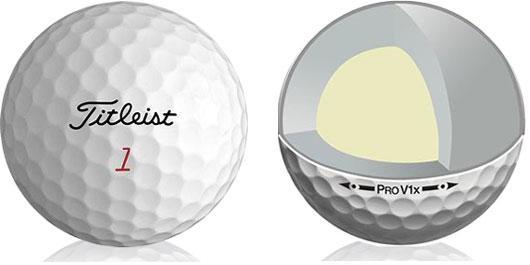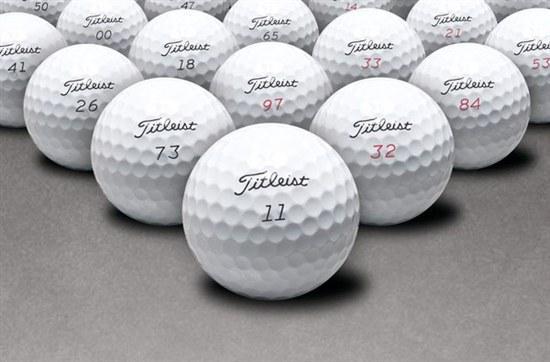The first image is the image on the left, the second image is the image on the right. Assess this claim about the two images: "There are exactly two golf balls". Correct or not? Answer yes or no. No. 